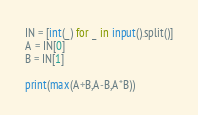Convert code to text. <code><loc_0><loc_0><loc_500><loc_500><_Python_>IN = [int(_) for _ in input().split()]
A = IN[0]
B = IN[1]

print(max(A+B,A-B,A*B))</code> 